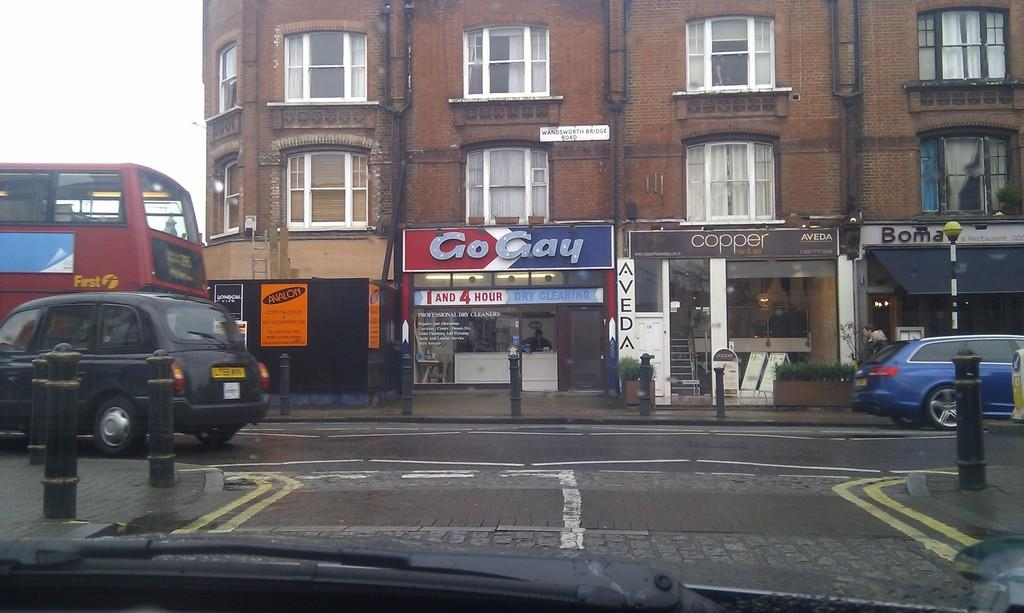<image>
Give a short and clear explanation of the subsequent image. Next to the Cooper store is a small dry cleaners called Go Gay. 